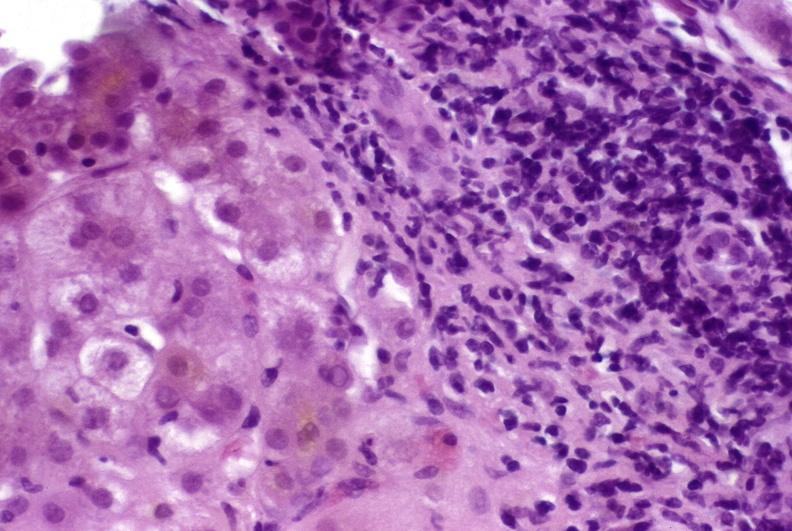what is present?
Answer the question using a single word or phrase. Liver 